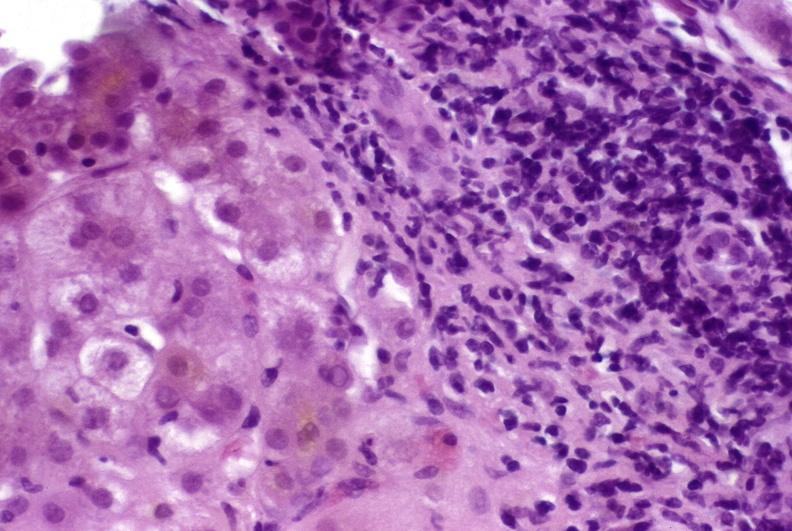what is present?
Answer the question using a single word or phrase. Liver 